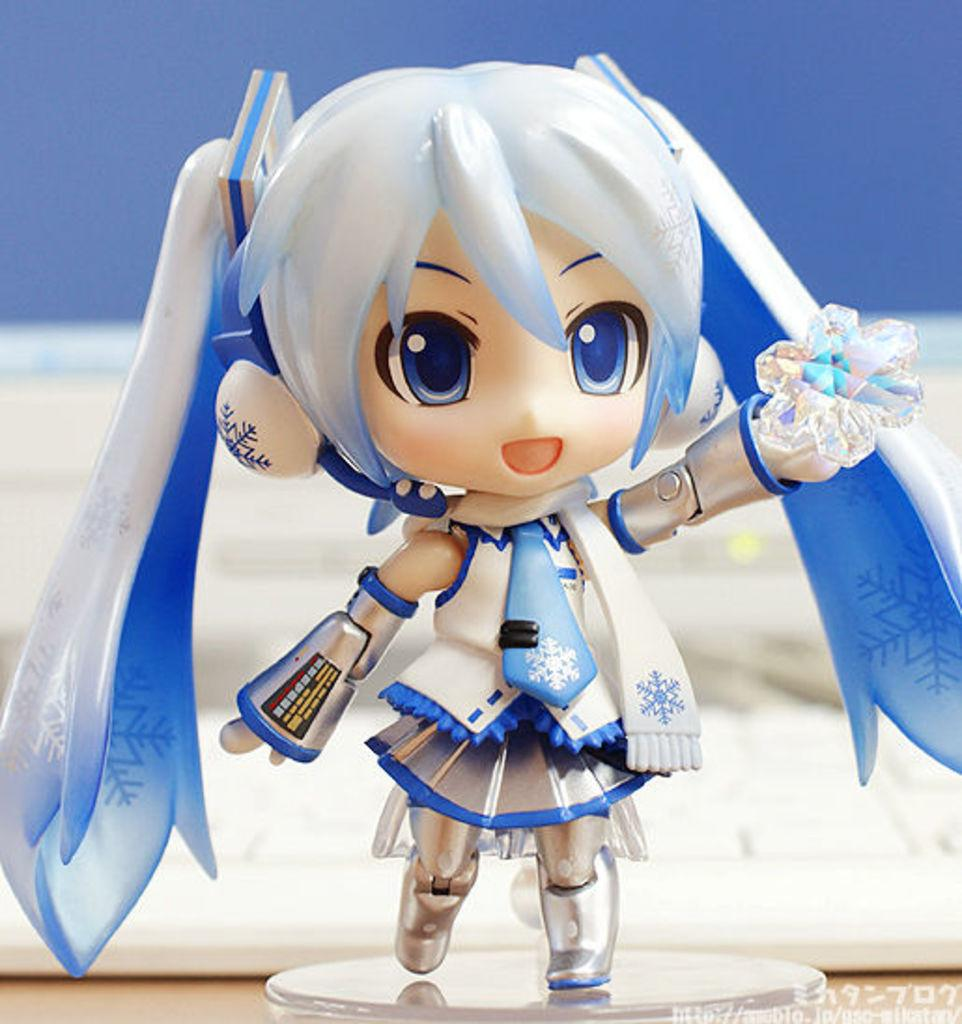What can be seen in the image besides the ground? There is a toy in the image, and it is on an object. Can you describe the appearance of the ground in the image? The ground is visible in the image. How would you describe the background of the image? The background of the image is blurred. Is there any text present in the image? Yes, there is some text in the bottom right corner of the image. What type of neck accessory is the toy wearing in the image? There is no neck accessory visible on the toy in the image. Are there any trousers present on the toy in the image? The toy in the image does not have any trousers. 